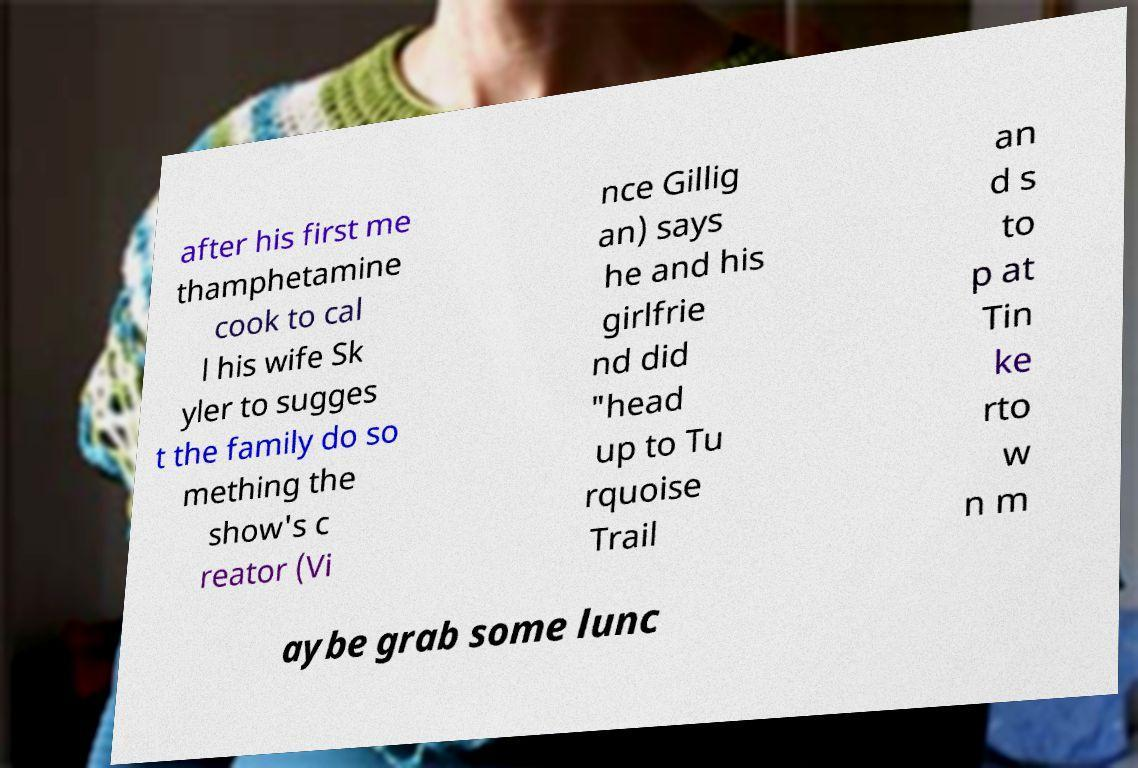Can you accurately transcribe the text from the provided image for me? after his first me thamphetamine cook to cal l his wife Sk yler to sugges t the family do so mething the show's c reator (Vi nce Gillig an) says he and his girlfrie nd did "head up to Tu rquoise Trail an d s to p at Tin ke rto w n m aybe grab some lunc 